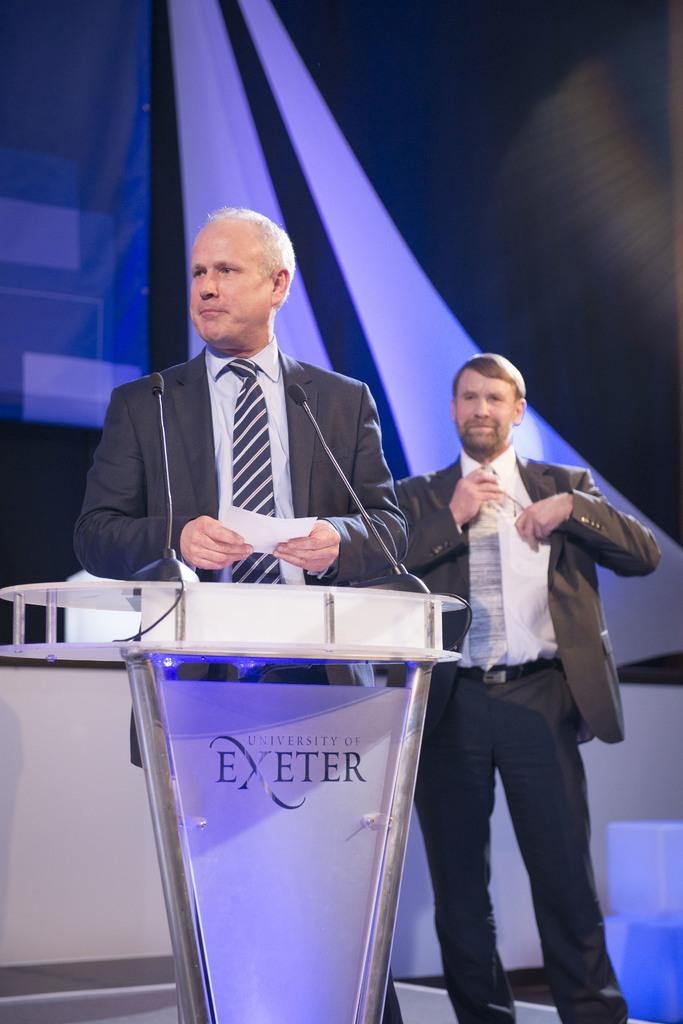<image>
Give a short and clear explanation of the subsequent image. a man is standing at an exeter podium with a card in his hands 